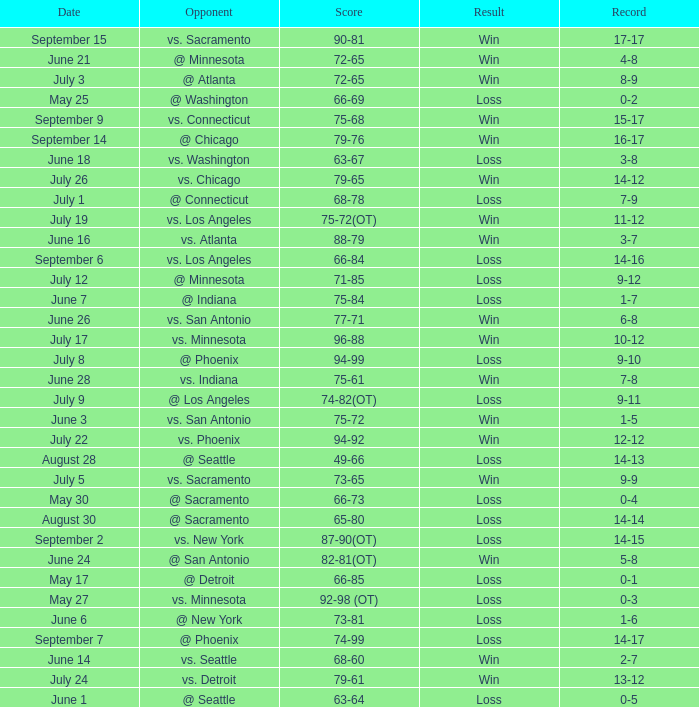What is the Date of the game with a Loss and Record of 7-9? July 1. 